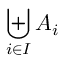Convert formula to latex. <formula><loc_0><loc_0><loc_500><loc_500>\Big u p l u s _ { i \in I } A _ { i }</formula> 